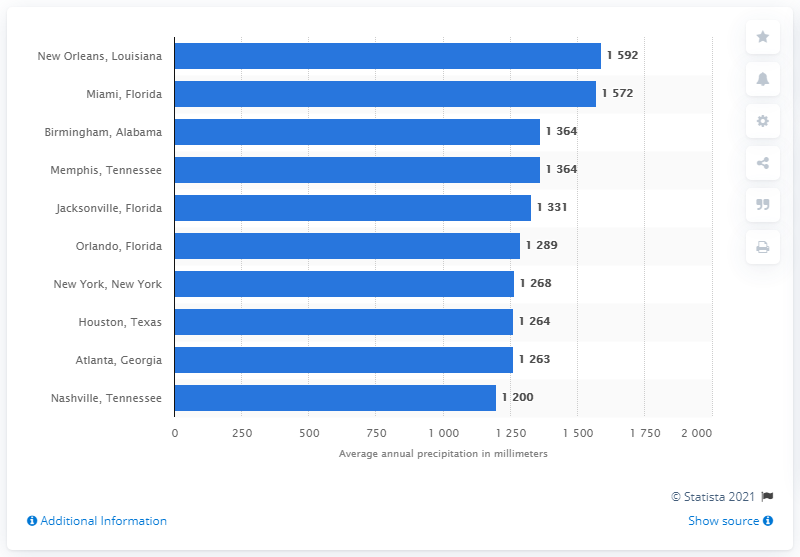Outline some significant characteristics in this image. New Orleans, Louisiana is the city with the most precipitation. 